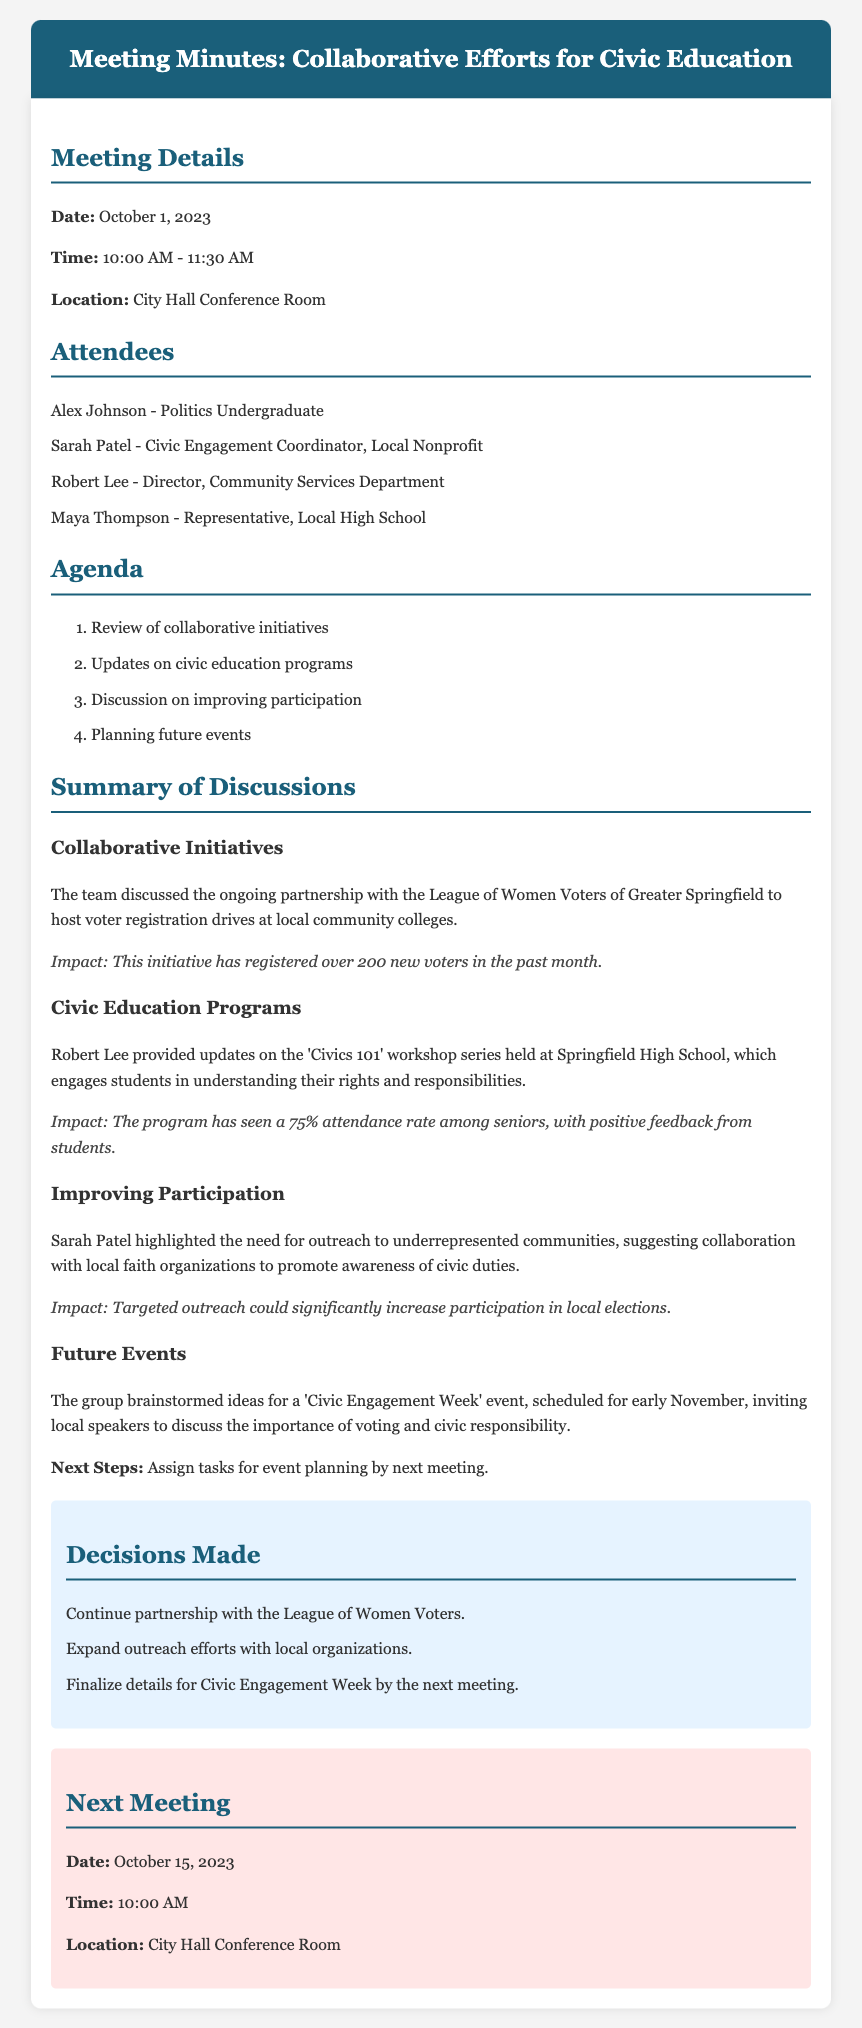what is the date of the meeting? The date of the meeting is specified in the document as October 1, 2023.
Answer: October 1, 2023 who is the Civic Engagement Coordinator mentioned in the attendees? The document lists Sarah Patel as the Civic Engagement Coordinator from a local nonprofit.
Answer: Sarah Patel what initiative was discussed to engage local community colleges? The document mentions a partnership with the League of Women Voters of Greater Springfield for voter registration drives.
Answer: voter registration drives how many new voters were registered in the past month? The document states that the initiative has registered over 200 new voters in the past month.
Answer: over 200 what is the attendance rate for the 'Civics 101' workshop series? The document notes that the program has seen a 75% attendance rate among seniors.
Answer: 75% what was suggested to improve outreach to underrepresented communities? The document indicates that collaboration with local faith organizations was suggested for promoting civic duties.
Answer: collaboration with local faith organizations when is the next meeting scheduled? The document specifies that the next meeting is on October 15, 2023.
Answer: October 15, 2023 what event is being planned for early November? The document mentions a 'Civic Engagement Week' event scheduled for early November.
Answer: Civic Engagement Week 